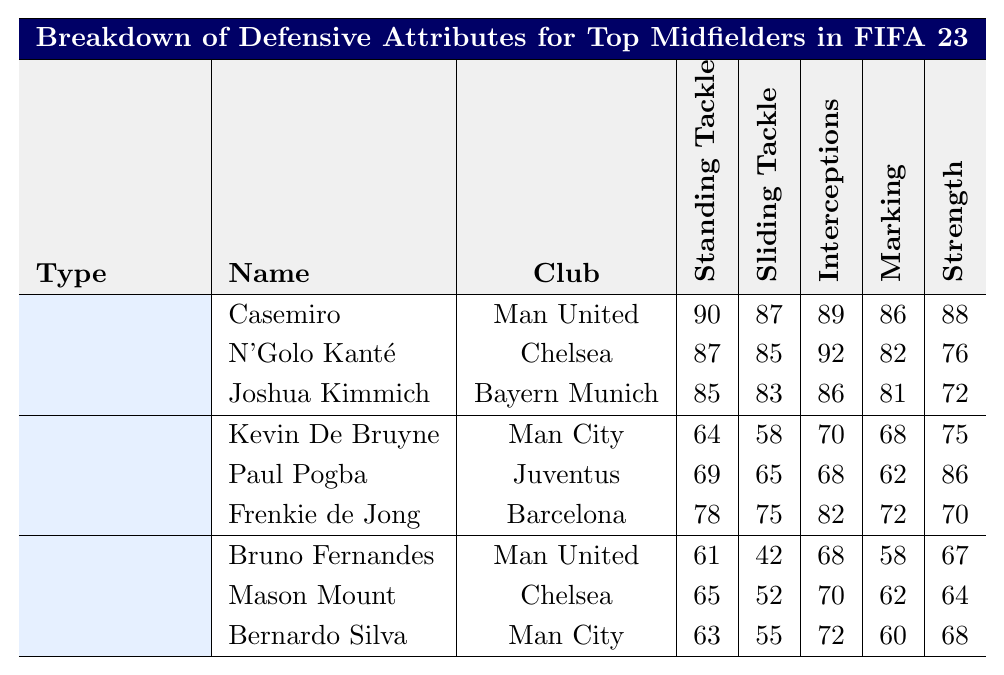What's the defensive rating for Casemiro? Refer to the row for Casemiro in the Defensive Midfielders section. His Overall Defensive Rating is listed as 88.
Answer: 88 What is the maximum value of Standing Tackle among listed midfielders? Looking through all midfielders in the table, Casemiro has the highest Standing Tackle rating at 90.
Answer: 90 Does N'Golo Kanté have a higher Interceptions rating than Joshua Kimmich? Check the Interceptions ratings for both players: Kanté has 92, while Kimmich has 86. Since 92 is greater than 86, the answer is yes.
Answer: Yes What is the average defensive rating of the Defensive Midfielders? The ratings for Casemiro (88), N'Golo Kanté (87), and Joshua Kimmich (84) sum to 259. Divide by three to get an average of 86.33.
Answer: 86.33 Which Box-to-Box Midfielder has the highest Strength rating? Review the Strength ratings of the Box-to-Box Midfielders: Kevin De Bruyne (75), Paul Pogba (86), and Frenkie de Jong (70). Paul Pogba has the highest at 86.
Answer: Paul Pogba Is Bruno Fernandes's Sliding Tackle rating greater than Mason Mount's? Compare their Sliding Tackle ratings: Fernandes has 42, while Mount has 52. Since 42 is less than 52, the answer is no.
Answer: No What is the total Interceptions rating of all Attacking Midfielders? The Interceptions ratings are: Bruno Fernandes (68), Mason Mount (70), and Bernardo Silva (72). Adding these gives a total of 210.
Answer: 210 Which midfielder has the lowest Overall Defensive Rating? Looking through the Overall Defensive Ratings, Bruno Fernandes has the lowest rating at 59.
Answer: Bruno Fernandes What is the difference between the highest and lowest Standing Tackle ratings among all midfielders? The highest Standing Tackle rating is 90 (Casemiro) and the lowest is 61 (Bruno Fernandes). The difference is 90 - 61 = 29.
Answer: 29 Which type of midfielder has the highest average Marking rating? Calculate the average Marking ratings: Defensive Midfielders average 86 (85, 82, 81), Box-to-Box Midfielders average 72.67 (68, 62, 72), and Attacking Midfielders average 60 (58, 62, 60). The highest is among Defensive Midfielders.
Answer: Defensive Midfielders 